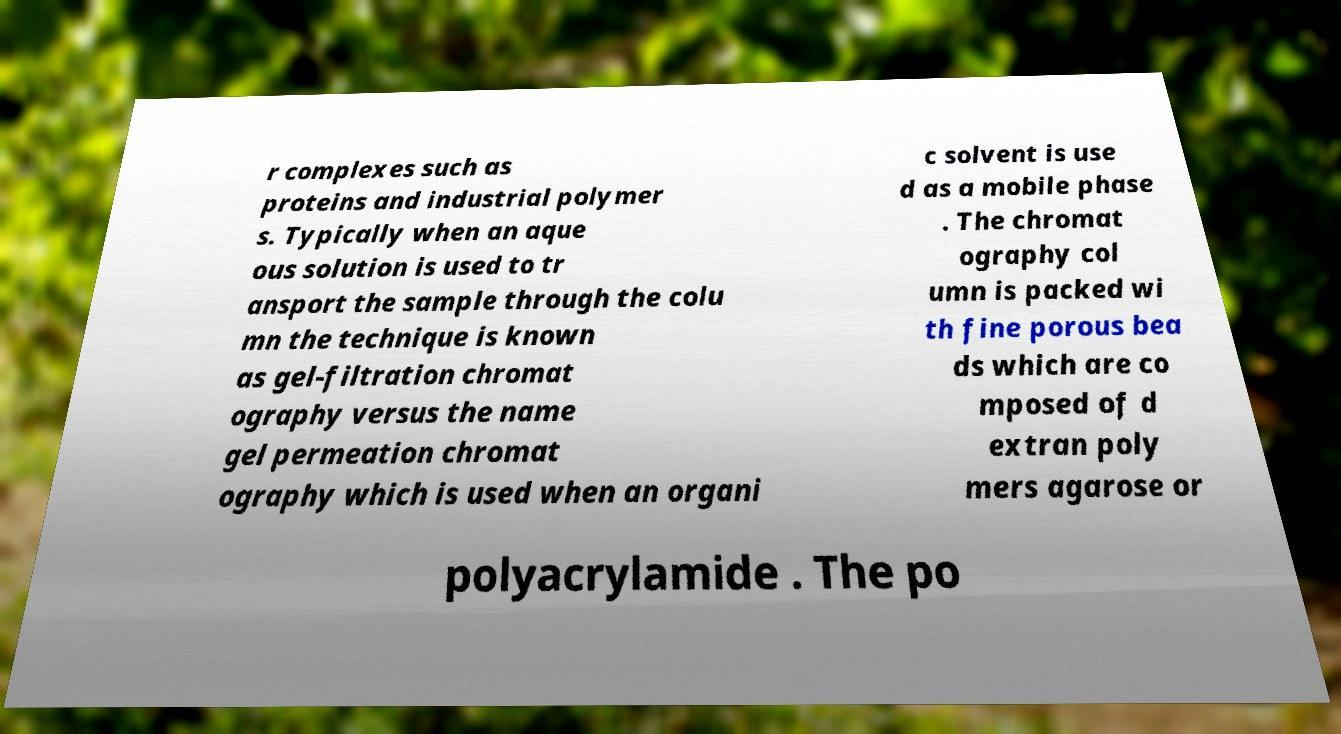Can you read and provide the text displayed in the image?This photo seems to have some interesting text. Can you extract and type it out for me? r complexes such as proteins and industrial polymer s. Typically when an aque ous solution is used to tr ansport the sample through the colu mn the technique is known as gel-filtration chromat ography versus the name gel permeation chromat ography which is used when an organi c solvent is use d as a mobile phase . The chromat ography col umn is packed wi th fine porous bea ds which are co mposed of d extran poly mers agarose or polyacrylamide . The po 